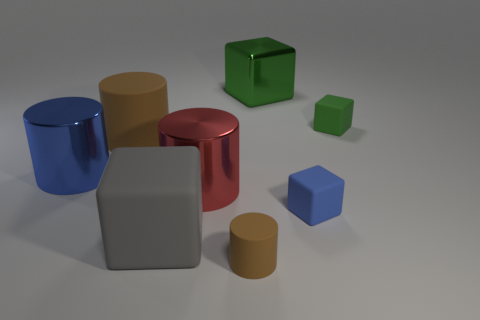The matte block that is the same color as the metal block is what size?
Offer a very short reply. Small. There is a small matte object that is the same color as the metal block; what is its shape?
Provide a succinct answer. Cube. What number of tiny green rubber blocks are there?
Keep it short and to the point. 1. The green thing that is made of the same material as the small blue object is what shape?
Your answer should be very brief. Cube. There is a matte cylinder in front of the blue thing on the left side of the blue rubber thing; how big is it?
Provide a short and direct response. Small. How many things are brown rubber things left of the tiny brown rubber thing or brown matte objects behind the large red object?
Offer a terse response. 1. Is the number of tiny rubber cylinders less than the number of big things?
Your answer should be compact. Yes. How many things are big red metallic objects or matte cylinders?
Your answer should be compact. 3. Is the small green rubber object the same shape as the big red metallic thing?
Offer a very short reply. No. Is there any other thing that is made of the same material as the big red cylinder?
Keep it short and to the point. Yes. 